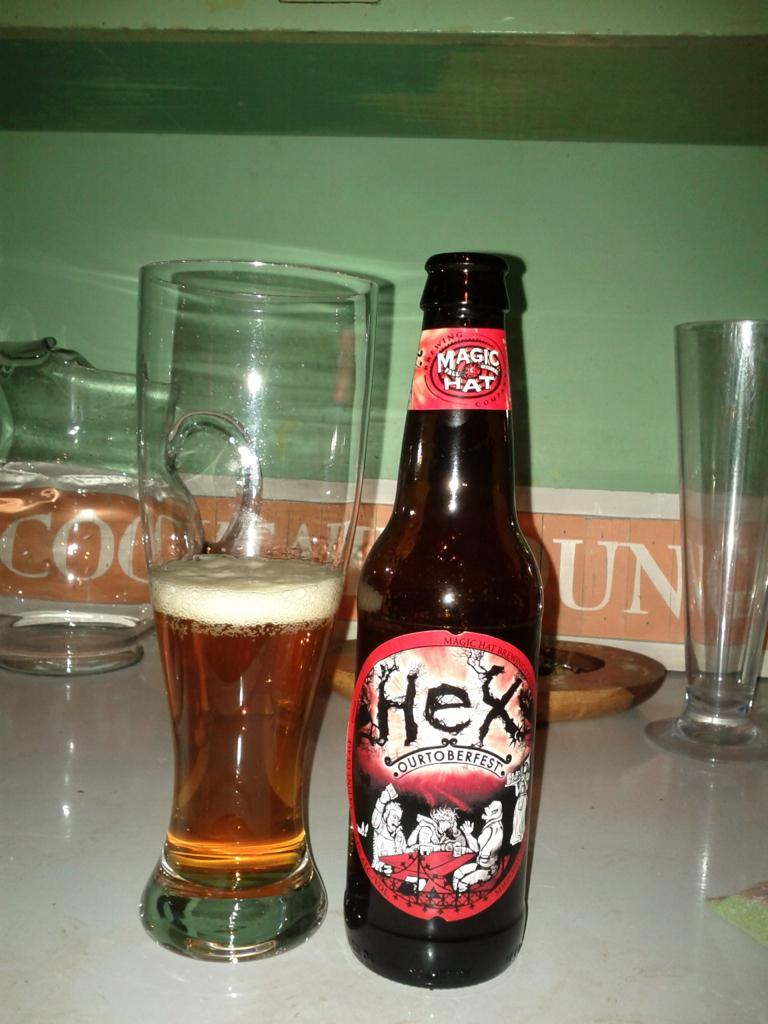<image>
Render a clear and concise summary of the photo. A bottle of Magic Hat Hex beer sits next to a half filled glass. 